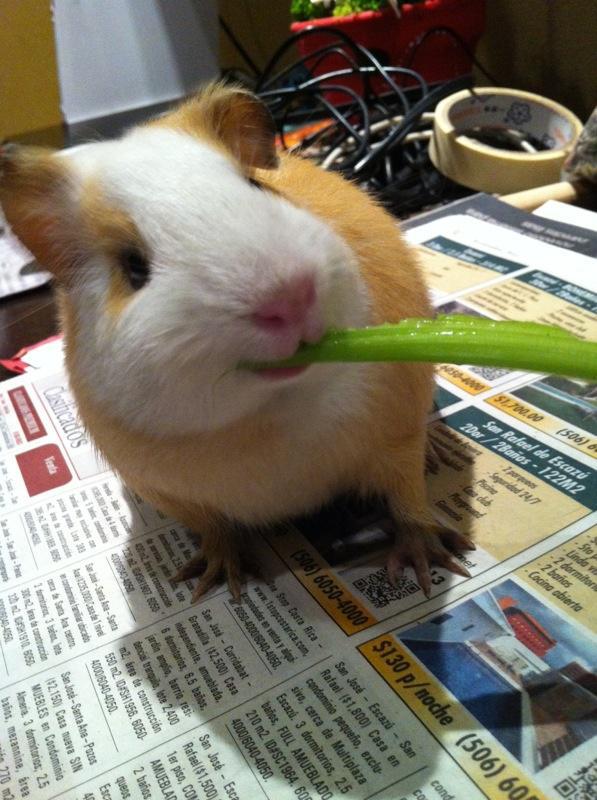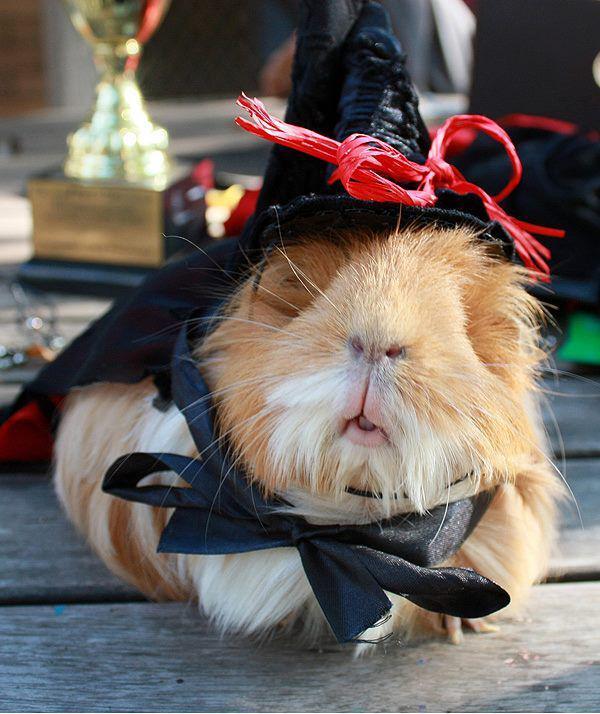The first image is the image on the left, the second image is the image on the right. Assess this claim about the two images: "An image shows a guinea pig having some type of snack.". Correct or not? Answer yes or no. Yes. The first image is the image on the left, the second image is the image on the right. Assess this claim about the two images: "There are exactly two animals in the image on the left.". Correct or not? Answer yes or no. No. The first image is the image on the left, the second image is the image on the right. Evaluate the accuracy of this statement regarding the images: "There are no more than 4 guinea pigs.". Is it true? Answer yes or no. Yes. The first image is the image on the left, the second image is the image on the right. Examine the images to the left and right. Is the description "At least one image features at least six guinea pigs." accurate? Answer yes or no. No. 